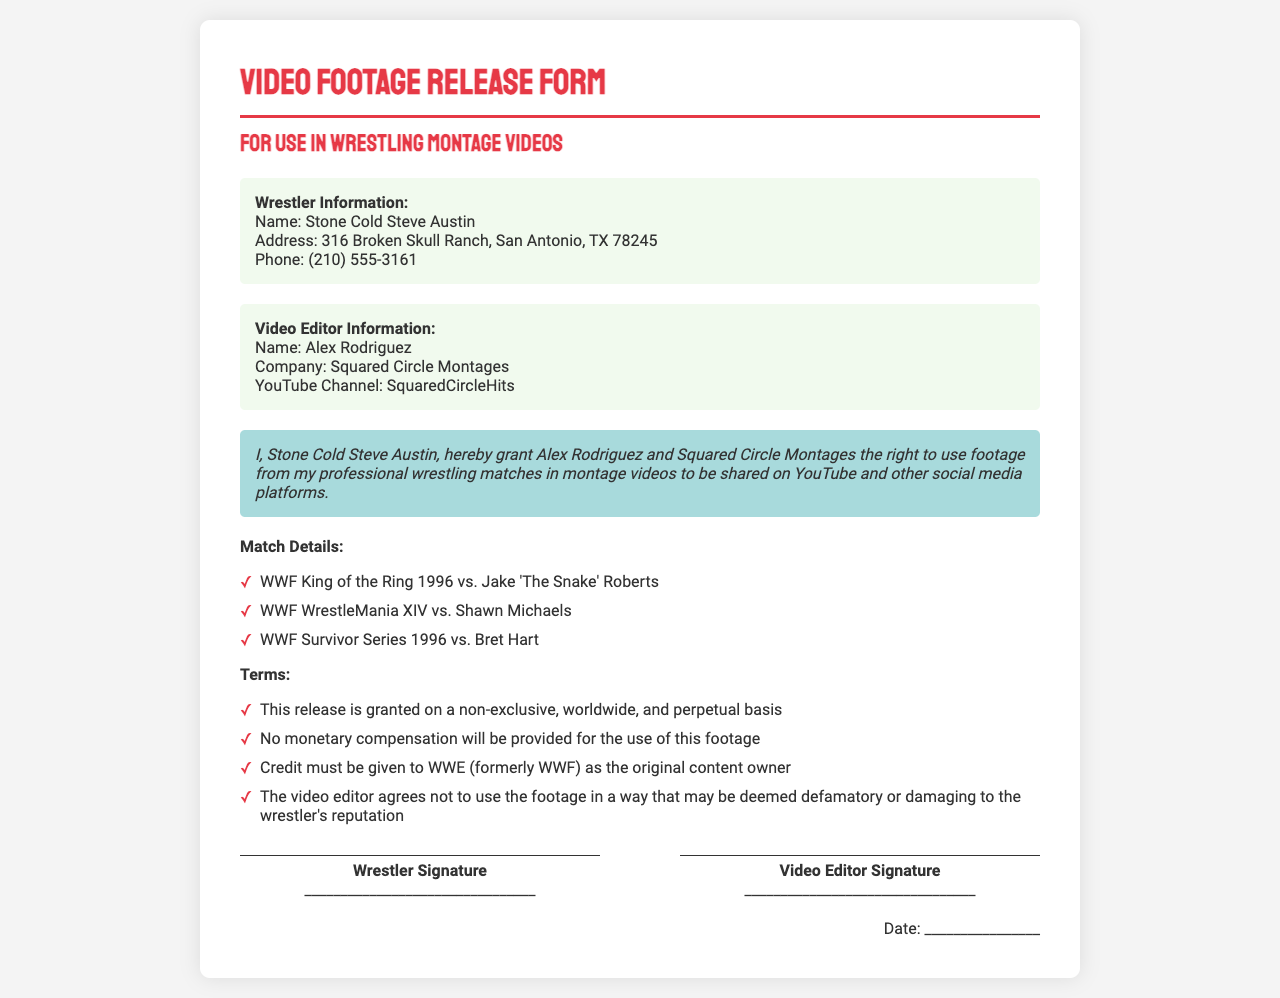What is the name of the wrestler? The name of the wrestler listed in the document is Stone Cold Steve Austin.
Answer: Stone Cold Steve Austin Who is the video editor? The name of the video editor mentioned in the document is Alex Rodriguez.
Answer: Alex Rodriguez What is the YouTube channel name? The YouTube channel associated with the video editor is given in the document.
Answer: SquaredCircleHits What is the address of the wrestler? The address provided in the document for the wrestler is 316 Broken Skull Ranch, San Antonio, TX 78245.
Answer: 316 Broken Skull Ranch, San Antonio, TX 78245 Which match is listed first? The first match listed in the document is a match from WWF King of the Ring 1996 against Jake 'The Snake' Roberts.
Answer: WWF King of the Ring 1996 vs. Jake 'The Snake' Roberts What is the compensation type for using the footage? The document states that there will be no monetary compensation for the use of the footage.
Answer: No monetary compensation What is the duration of the release granted? The release is granted on a non-exclusive, worldwide, and perpetual basis, which describes its duration.
Answer: Perpetual What does the video editor agree not to do with the footage? The video editor agrees not to use the footage in a way that may damage the wrestler's reputation, as stated in the document.
Answer: Damaging to the wrestler's reputation On which platform will the montage videos be shared? The document specifies that the montage videos will be shared on YouTube and other social media platforms.
Answer: YouTube and other social media platforms 